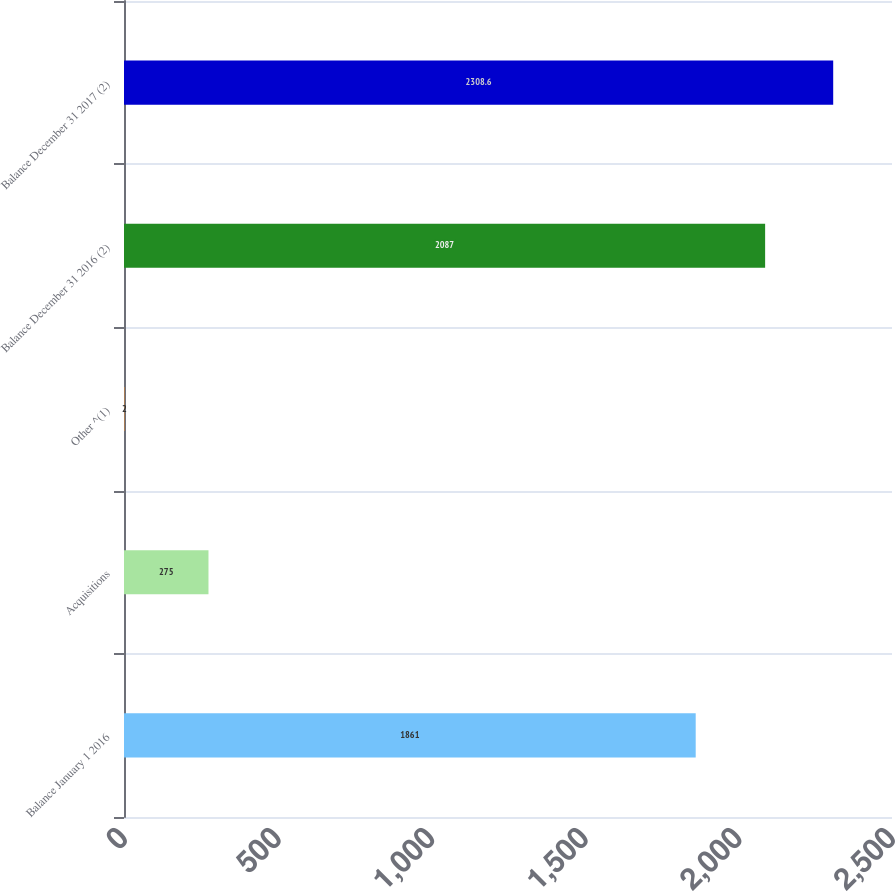Convert chart to OTSL. <chart><loc_0><loc_0><loc_500><loc_500><bar_chart><fcel>Balance January 1 2016<fcel>Acquisitions<fcel>Other ^(1)<fcel>Balance December 31 2016 (2)<fcel>Balance December 31 2017 (2)<nl><fcel>1861<fcel>275<fcel>2<fcel>2087<fcel>2308.6<nl></chart> 